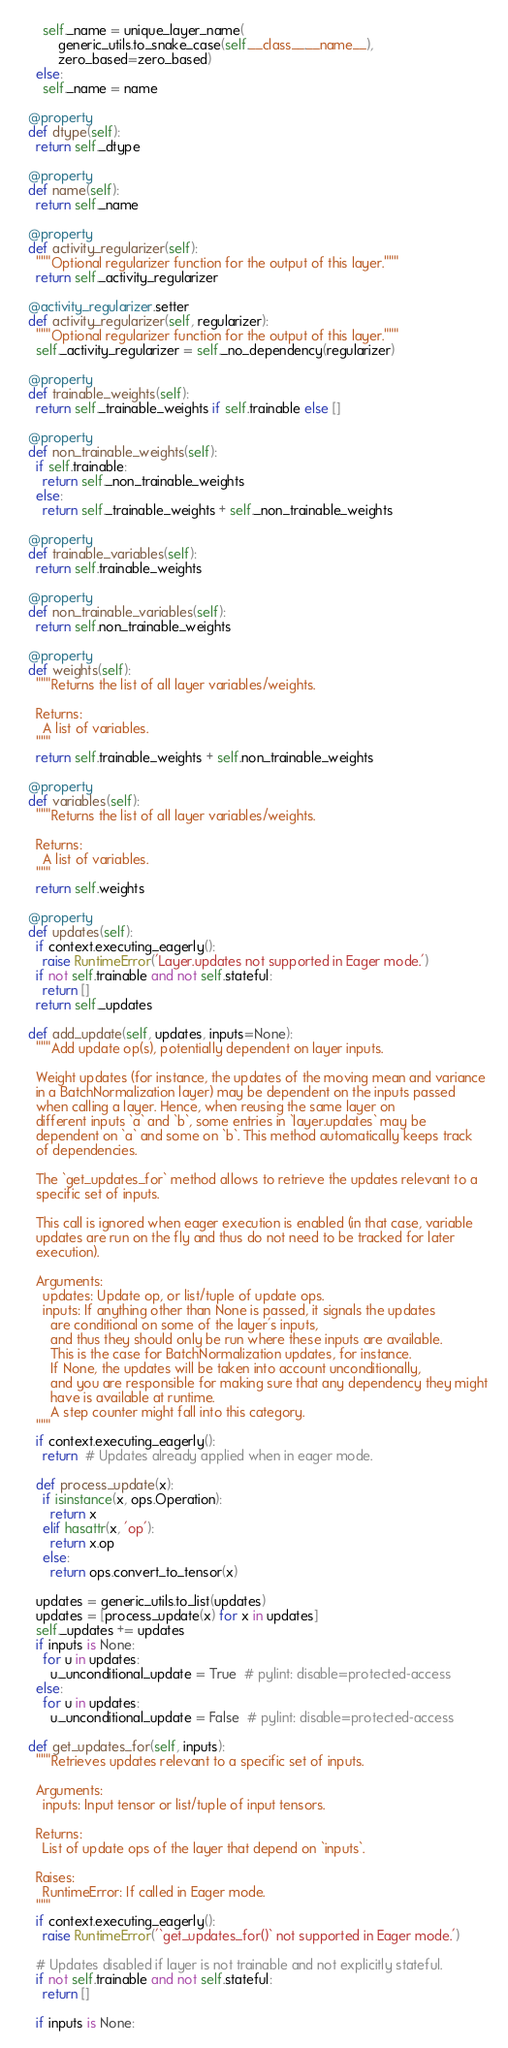<code> <loc_0><loc_0><loc_500><loc_500><_Python_>      self._name = unique_layer_name(
          generic_utils.to_snake_case(self.__class__.__name__),
          zero_based=zero_based)
    else:
      self._name = name

  @property
  def dtype(self):
    return self._dtype

  @property
  def name(self):
    return self._name

  @property
  def activity_regularizer(self):
    """Optional regularizer function for the output of this layer."""
    return self._activity_regularizer

  @activity_regularizer.setter
  def activity_regularizer(self, regularizer):
    """Optional regularizer function for the output of this layer."""
    self._activity_regularizer = self._no_dependency(regularizer)

  @property
  def trainable_weights(self):
    return self._trainable_weights if self.trainable else []

  @property
  def non_trainable_weights(self):
    if self.trainable:
      return self._non_trainable_weights
    else:
      return self._trainable_weights + self._non_trainable_weights

  @property
  def trainable_variables(self):
    return self.trainable_weights

  @property
  def non_trainable_variables(self):
    return self.non_trainable_weights

  @property
  def weights(self):
    """Returns the list of all layer variables/weights.

    Returns:
      A list of variables.
    """
    return self.trainable_weights + self.non_trainable_weights

  @property
  def variables(self):
    """Returns the list of all layer variables/weights.

    Returns:
      A list of variables.
    """
    return self.weights

  @property
  def updates(self):
    if context.executing_eagerly():
      raise RuntimeError('Layer.updates not supported in Eager mode.')
    if not self.trainable and not self.stateful:
      return []
    return self._updates

  def add_update(self, updates, inputs=None):
    """Add update op(s), potentially dependent on layer inputs.

    Weight updates (for instance, the updates of the moving mean and variance
    in a BatchNormalization layer) may be dependent on the inputs passed
    when calling a layer. Hence, when reusing the same layer on
    different inputs `a` and `b`, some entries in `layer.updates` may be
    dependent on `a` and some on `b`. This method automatically keeps track
    of dependencies.

    The `get_updates_for` method allows to retrieve the updates relevant to a
    specific set of inputs.

    This call is ignored when eager execution is enabled (in that case, variable
    updates are run on the fly and thus do not need to be tracked for later
    execution).

    Arguments:
      updates: Update op, or list/tuple of update ops.
      inputs: If anything other than None is passed, it signals the updates
        are conditional on some of the layer's inputs,
        and thus they should only be run where these inputs are available.
        This is the case for BatchNormalization updates, for instance.
        If None, the updates will be taken into account unconditionally,
        and you are responsible for making sure that any dependency they might
        have is available at runtime.
        A step counter might fall into this category.
    """
    if context.executing_eagerly():
      return  # Updates already applied when in eager mode.

    def process_update(x):
      if isinstance(x, ops.Operation):
        return x
      elif hasattr(x, 'op'):
        return x.op
      else:
        return ops.convert_to_tensor(x)

    updates = generic_utils.to_list(updates)
    updates = [process_update(x) for x in updates]
    self._updates += updates
    if inputs is None:
      for u in updates:
        u._unconditional_update = True  # pylint: disable=protected-access
    else:
      for u in updates:
        u._unconditional_update = False  # pylint: disable=protected-access

  def get_updates_for(self, inputs):
    """Retrieves updates relevant to a specific set of inputs.

    Arguments:
      inputs: Input tensor or list/tuple of input tensors.

    Returns:
      List of update ops of the layer that depend on `inputs`.

    Raises:
      RuntimeError: If called in Eager mode.
    """
    if context.executing_eagerly():
      raise RuntimeError('`get_updates_for()` not supported in Eager mode.')

    # Updates disabled if layer is not trainable and not explicitly stateful.
    if not self.trainable and not self.stateful:
      return []

    if inputs is None:</code> 